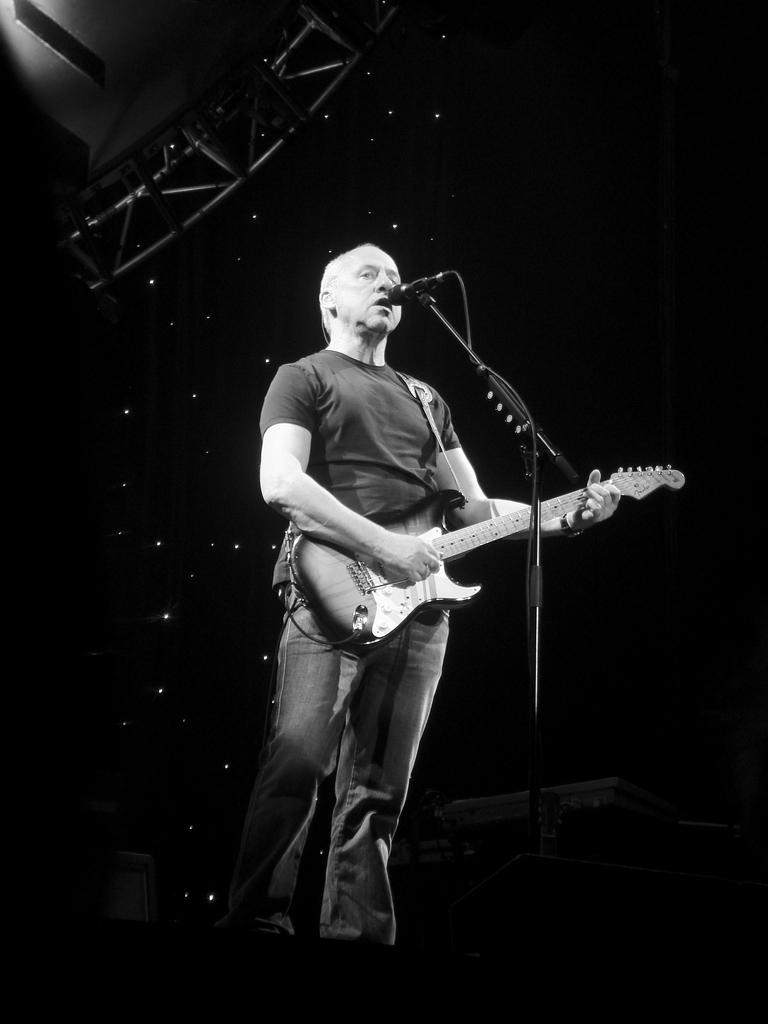What is the person in the image doing? The person is playing a guitar and singing. What instrument is the person using to play music? The person is playing a guitar. What device is present for amplifying the person's voice? There is a microphone with a stand in the image. What can be seen at the top of the image? There are lights visible at the top of the image. Where is the drum located in the image? There is no drum present in the image. Can you see a squirrel playing with the microphone in the image? There is no squirrel present in the image. 